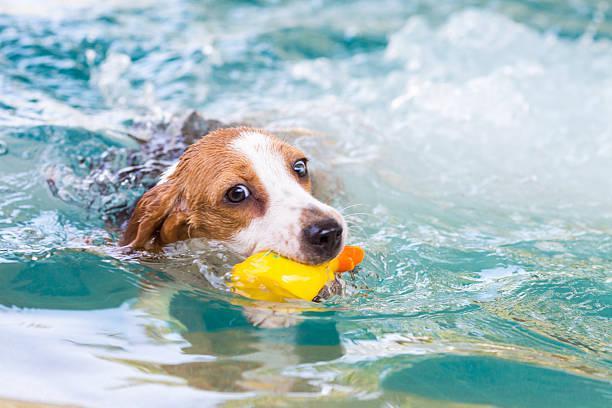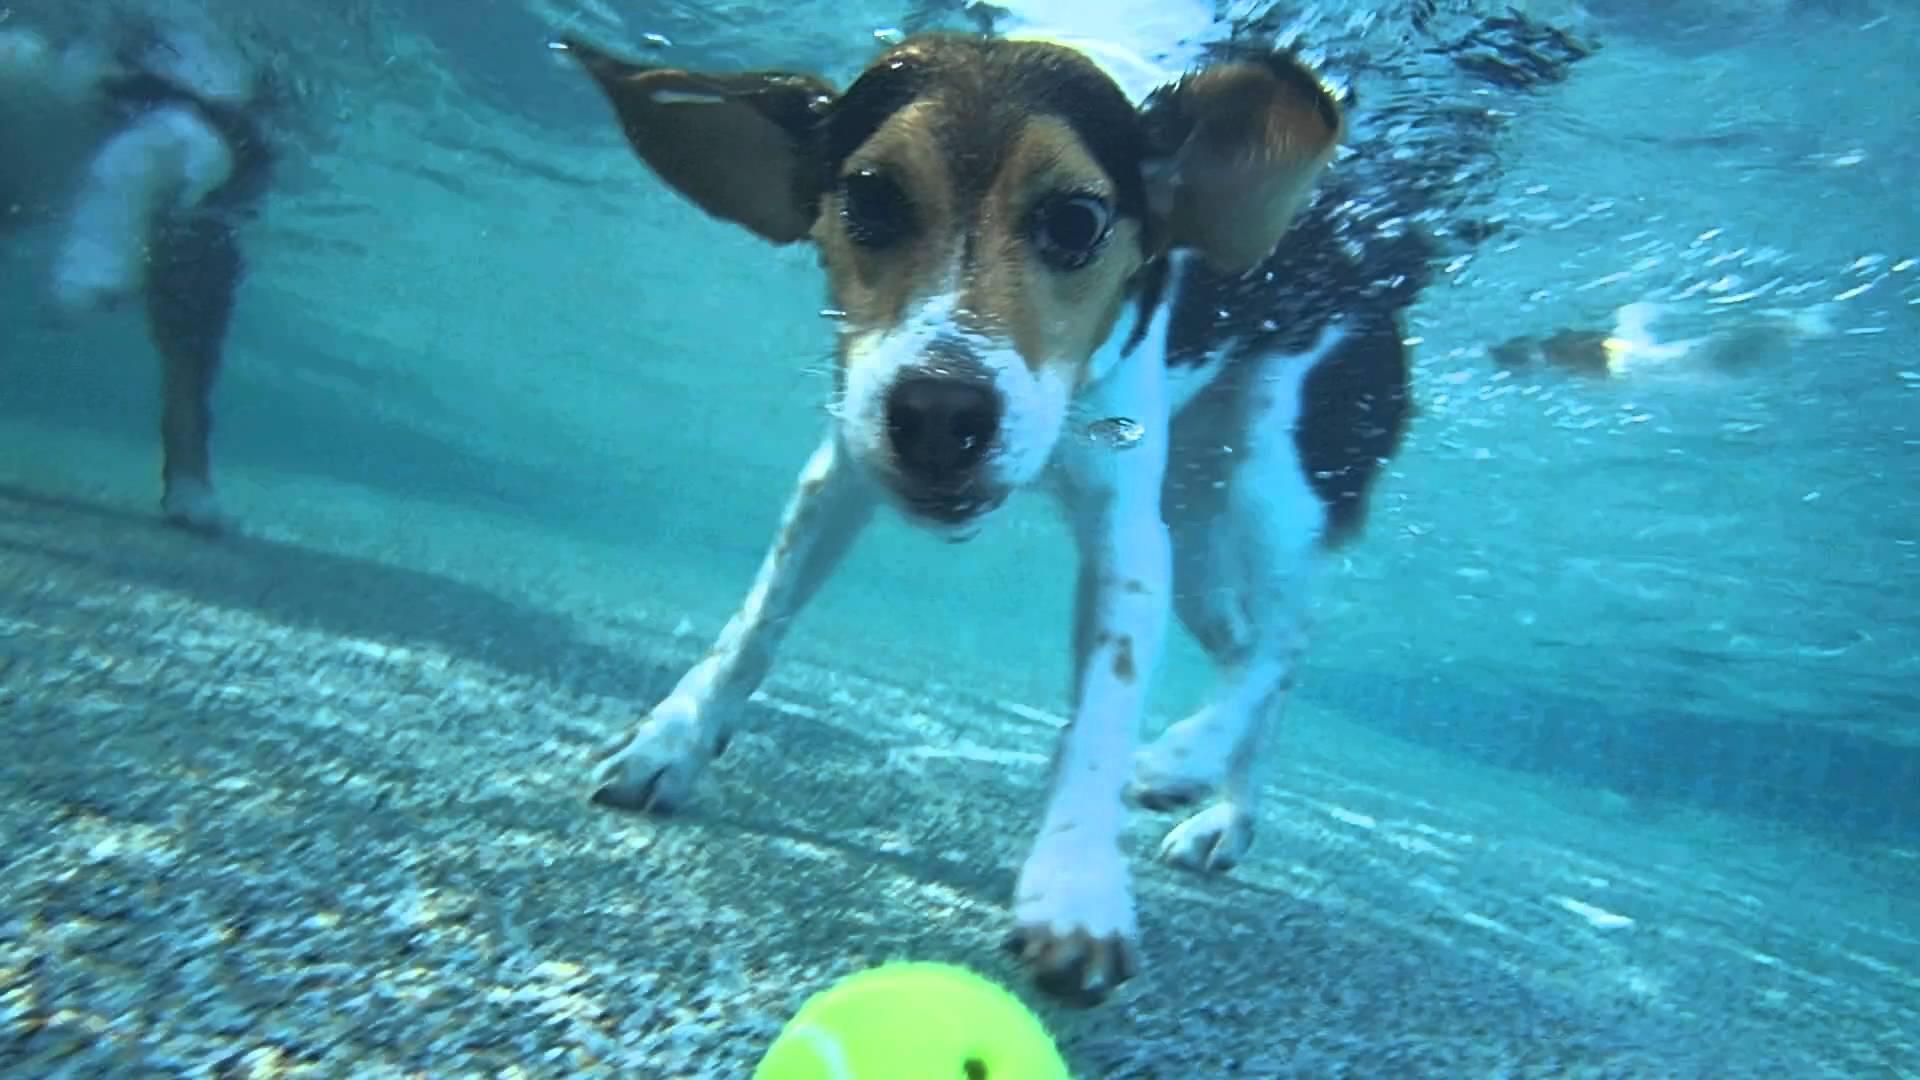The first image is the image on the left, the second image is the image on the right. Examine the images to the left and right. Is the description "The dog on the right image has its head under water." accurate? Answer yes or no. Yes. The first image is the image on the left, the second image is the image on the right. For the images shown, is this caption "a dog is swimming with a toy in its mouth" true? Answer yes or no. Yes. 